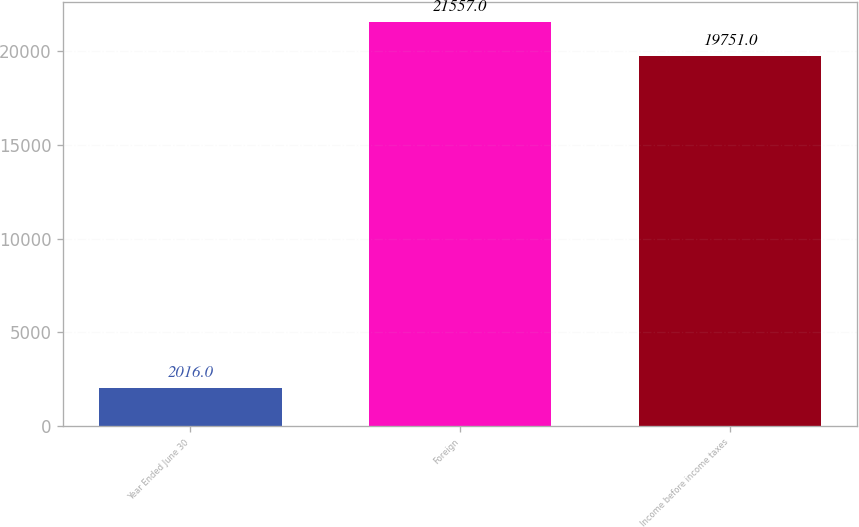Convert chart to OTSL. <chart><loc_0><loc_0><loc_500><loc_500><bar_chart><fcel>Year Ended June 30<fcel>Foreign<fcel>Income before income taxes<nl><fcel>2016<fcel>21557<fcel>19751<nl></chart> 